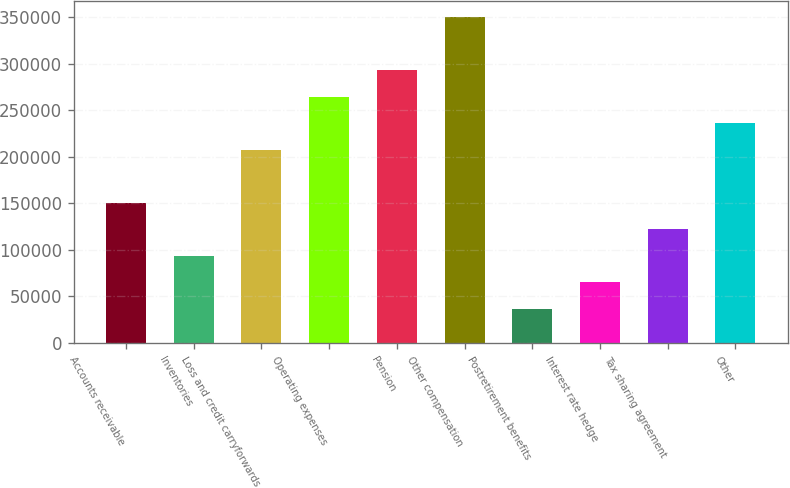<chart> <loc_0><loc_0><loc_500><loc_500><bar_chart><fcel>Accounts receivable<fcel>Inventories<fcel>Loss and credit carryforwards<fcel>Operating expenses<fcel>Pension<fcel>Other compensation<fcel>Postretirement benefits<fcel>Interest rate hedge<fcel>Tax sharing agreement<fcel>Other<nl><fcel>150603<fcel>93643.8<fcel>207562<fcel>264521<fcel>293001<fcel>349960<fcel>36684.6<fcel>65164.2<fcel>122123<fcel>236042<nl></chart> 